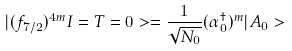Convert formula to latex. <formula><loc_0><loc_0><loc_500><loc_500>| ( f _ { 7 / 2 } ) ^ { 4 m } I = T = 0 > = \frac { 1 } { \sqrt { N _ { 0 } } } ( \alpha _ { 0 } ^ { \dagger } ) ^ { m } | A _ { 0 } ></formula> 